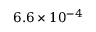Convert formula to latex. <formula><loc_0><loc_0><loc_500><loc_500>6 . 6 \times 1 0 ^ { - 4 }</formula> 